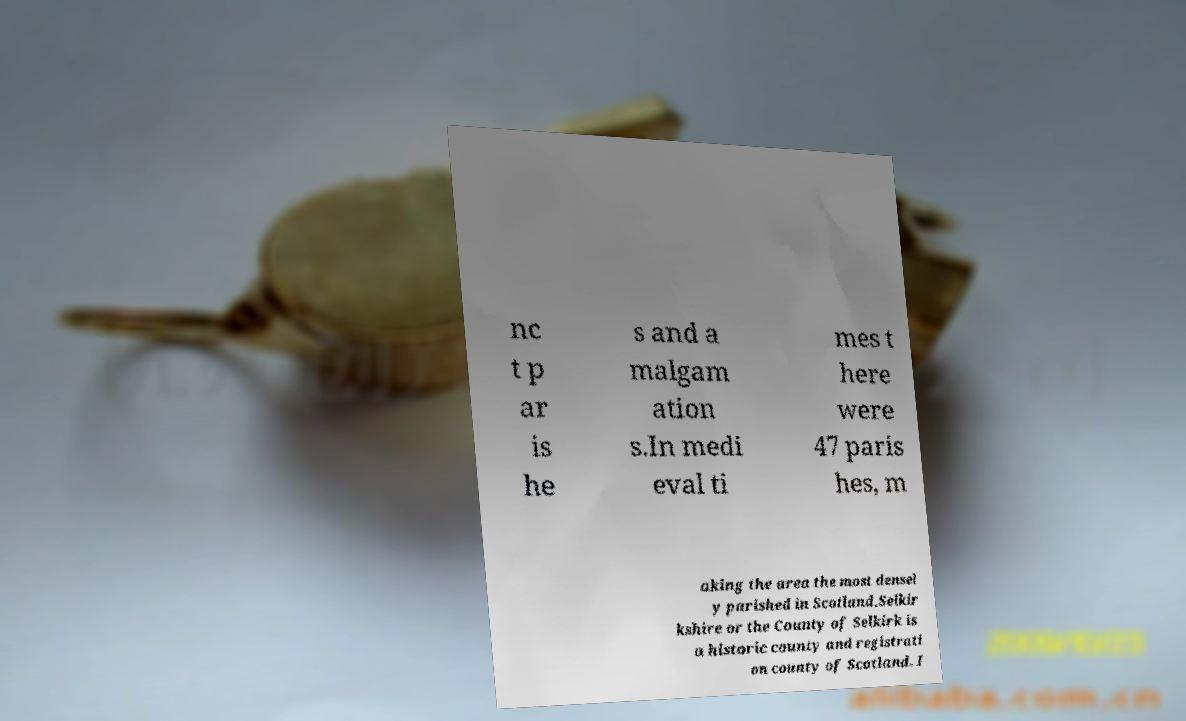What messages or text are displayed in this image? I need them in a readable, typed format. nc t p ar is he s and a malgam ation s.In medi eval ti mes t here were 47 paris hes, m aking the area the most densel y parished in Scotland.Selkir kshire or the County of Selkirk is a historic county and registrati on county of Scotland. I 